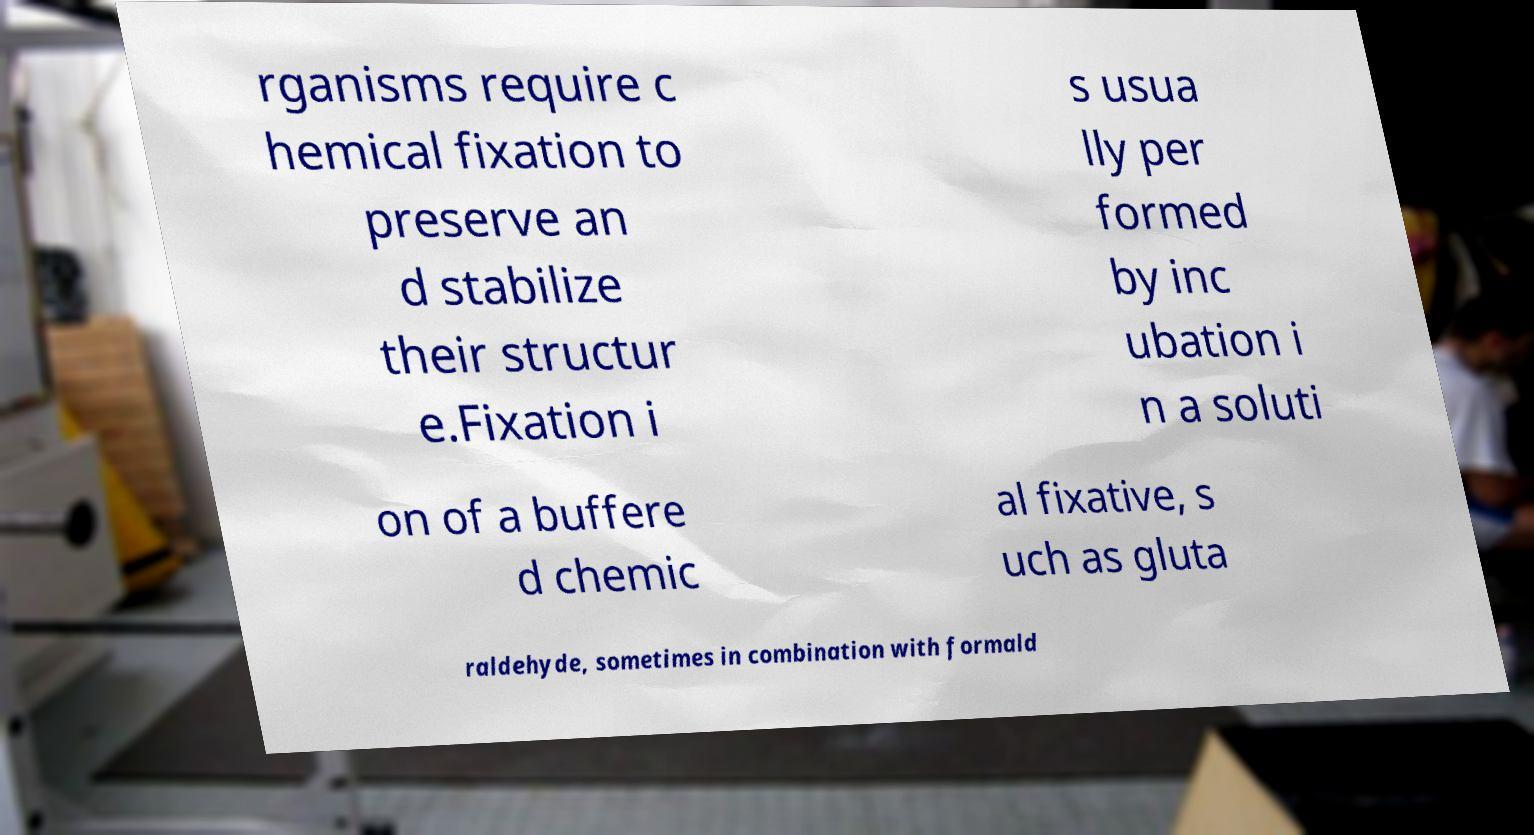Please identify and transcribe the text found in this image. rganisms require c hemical fixation to preserve an d stabilize their structur e.Fixation i s usua lly per formed by inc ubation i n a soluti on of a buffere d chemic al fixative, s uch as gluta raldehyde, sometimes in combination with formald 